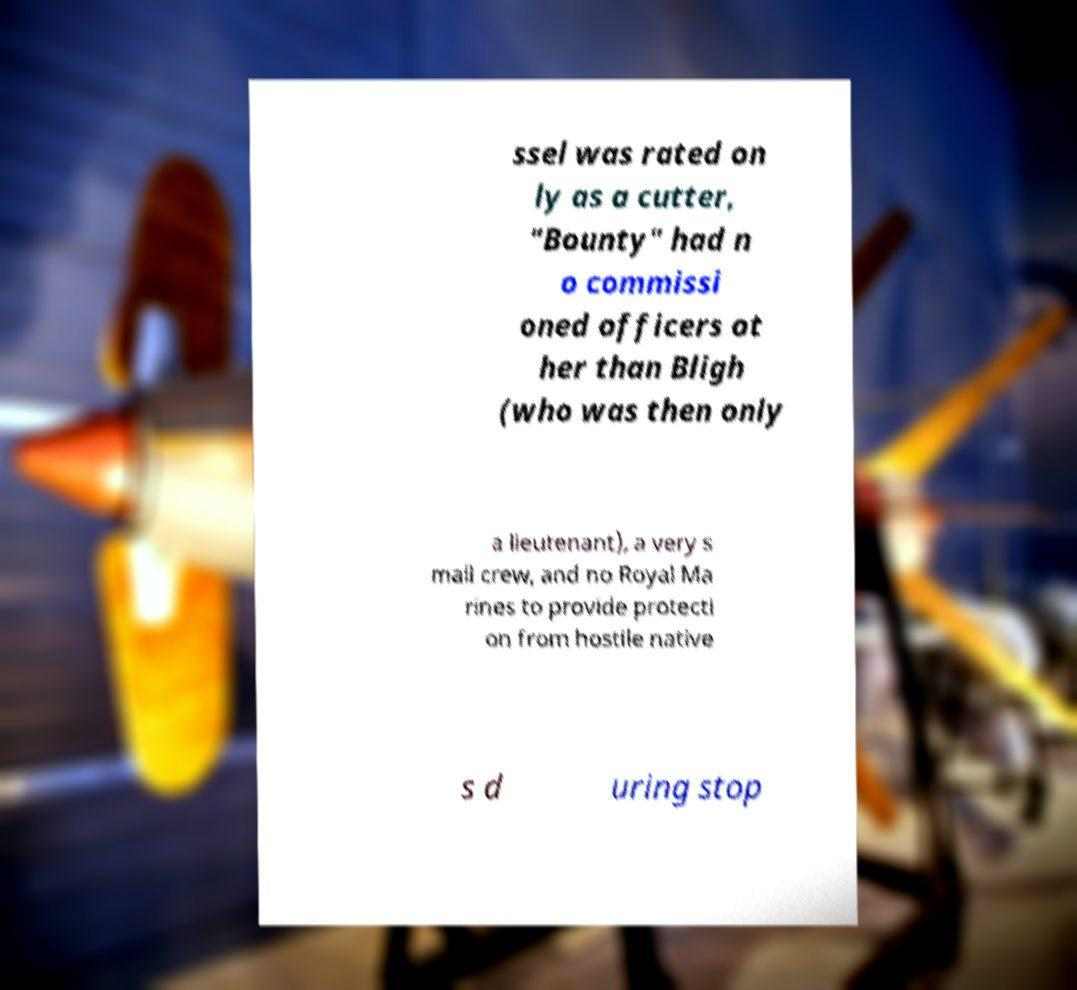Please identify and transcribe the text found in this image. ssel was rated on ly as a cutter, "Bounty" had n o commissi oned officers ot her than Bligh (who was then only a lieutenant), a very s mall crew, and no Royal Ma rines to provide protecti on from hostile native s d uring stop 